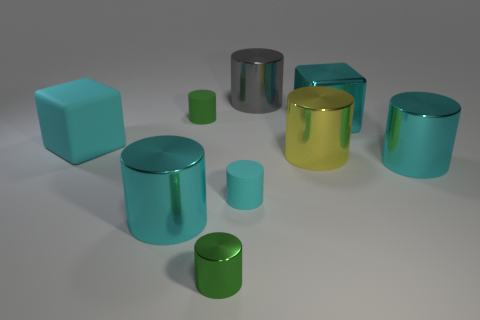How many cyan cylinders must be subtracted to get 1 cyan cylinders? 2 Subtract all brown blocks. How many cyan cylinders are left? 3 Subtract 3 cylinders. How many cylinders are left? 4 Subtract all tiny green matte cylinders. How many cylinders are left? 6 Subtract all green cylinders. How many cylinders are left? 5 Subtract all blue cylinders. Subtract all gray blocks. How many cylinders are left? 7 Add 1 big yellow metal things. How many objects exist? 10 Subtract all cubes. How many objects are left? 7 Add 4 small rubber cylinders. How many small rubber cylinders are left? 6 Add 2 small matte things. How many small matte things exist? 4 